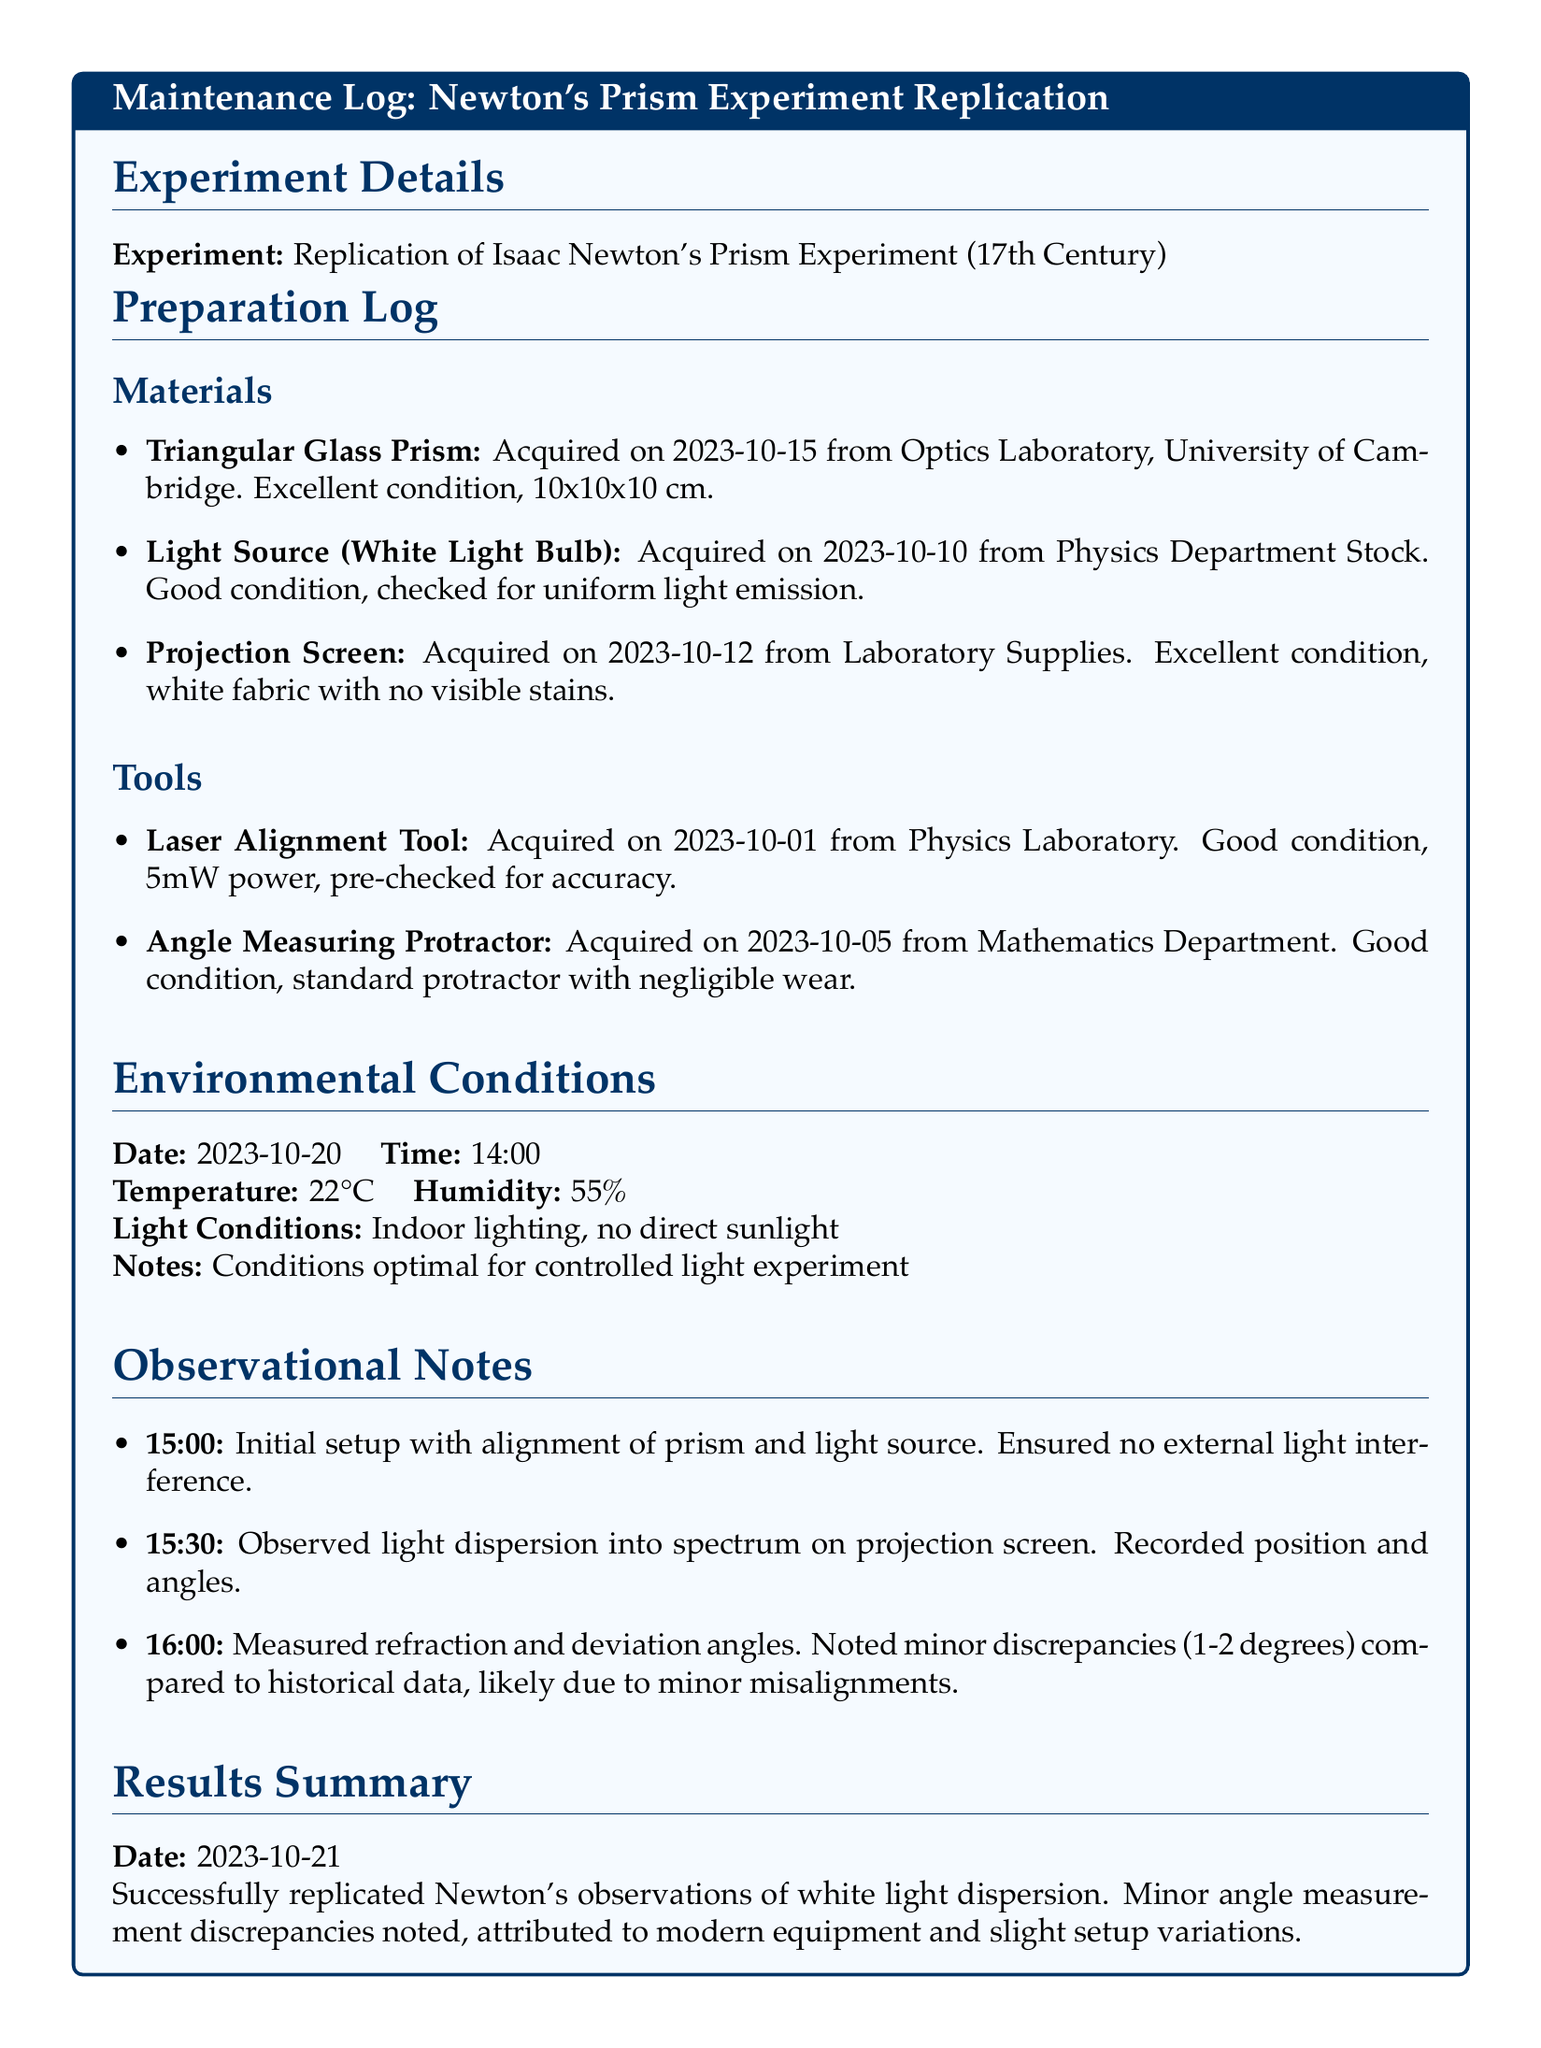What is the date of the experiment? The experiment took place on October 20, 2023.
Answer: October 20, 2023 What type of prism was used in the experiment? The document specifies a triangular glass prism was used.
Answer: Triangular Glass Prism Who acquired the triangular glass prism? The prism was acquired from the Optics Laboratory at the University of Cambridge.
Answer: Optics Laboratory, University of Cambridge What was the temperature during the experiment? The temperature recorded was 22 degrees Celsius.
Answer: 22°C What discrepancies were noted during the experiment? The discrepancies noted were minor, specifically 1-2 degrees compared to historical data.
Answer: 1-2 degrees When was the light source acquired? The light source was acquired on October 10, 2023.
Answer: October 10, 2023 How was the light emission of the light source described? The light emission was described as uniform.
Answer: Uniform light emission What were the environmental humidity conditions? The humidity conditions were recorded at 55 percent.
Answer: 55% What was the date of the results summary? The results summary was dated October 21, 2023.
Answer: October 21, 2023 What was observed at 15:30? At 15:30, light dispersion into a spectrum on the projection screen was observed.
Answer: Light dispersion into spectrum 